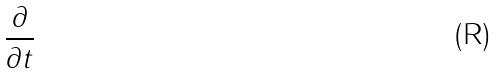<formula> <loc_0><loc_0><loc_500><loc_500>\frac { \partial } { \partial t }</formula> 